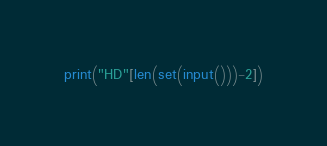<code> <loc_0><loc_0><loc_500><loc_500><_Python_>print("HD"[len(set(input()))-2])</code> 